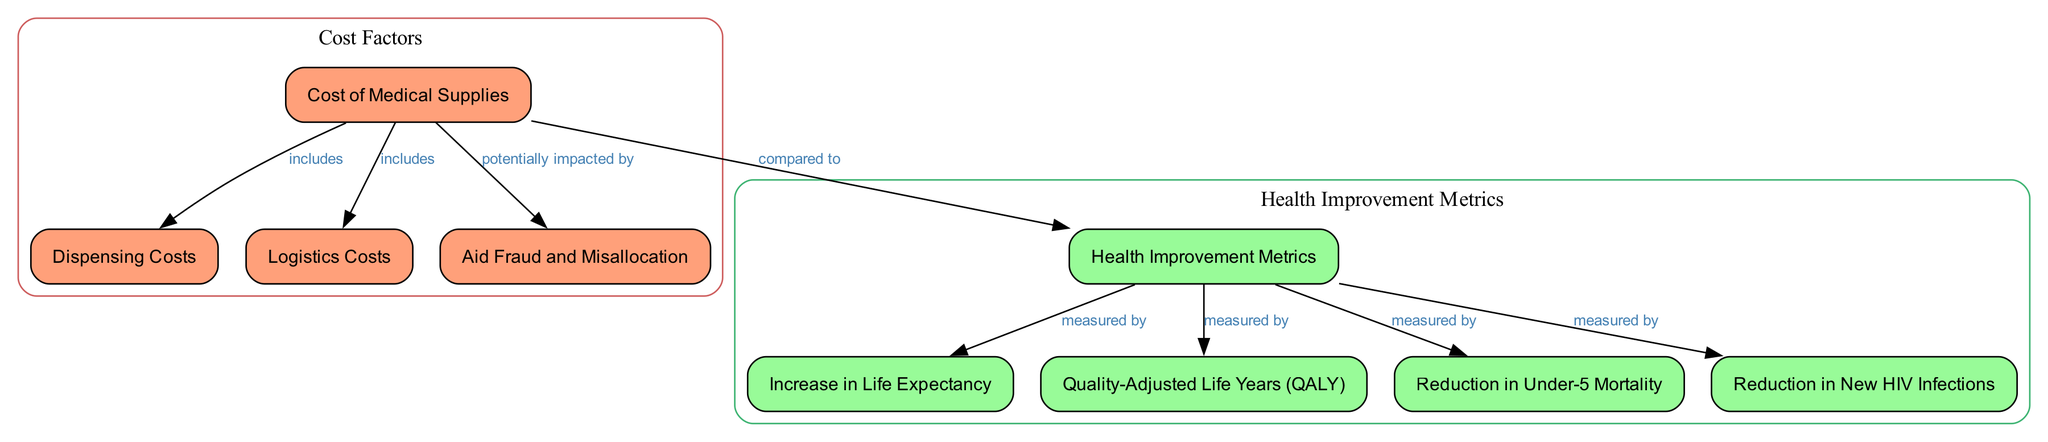What are the two types of costs associated with medical supply distribution? The diagram specifies that there are two types of costs related to medical supply distribution: dispensing costs and logistics costs. These are branches that fall under the main node labeled "Cost of Medical Supplies."
Answer: dispensing costs, logistics costs What is one potential issue that could impact the cost of medical supplies? The diagram identifies "Aid Fraud and Misallocation" as a factor that could potentially impact the overall cost of medical supplies. This is linked to the main cost node in the diagram.
Answer: Aid Fraud and Misallocation How many health improvement metrics are measured in the diagram? The diagram shows a total of four health improvement metrics: Increase in Life Expectancy, Quality-Adjusted Life Years (QALY), Reduction in Under-5 Mortality, and Reduction in New HIV Infections. These metrics are linked to the health improvement node.
Answer: four Which health improvement metric is associated with life expectancy? The diagram shows that life expectancy is a specific metric measured by the overall health improvement node. It is directly connected to the health improvement metrics within the diagram.
Answer: Increase in Life Expectancy What do the logistic costs include? Based on the diagram, logistic costs are included under the main cost node, which is linked to cost factors related to medical supplies. Therefore, it represents one type of cost associated with these supplies.
Answer: included under cost node How does aid fraud affect costs? The diagram indicates that aid fraud and misallocation is a factor that potentially impacts the costs of medical supply distribution. This implies that inefficiencies or corruption in aid delivery may lead to increased costs in the overall expenditure needed for effective distribution.
Answer: potentially impacted by costs 